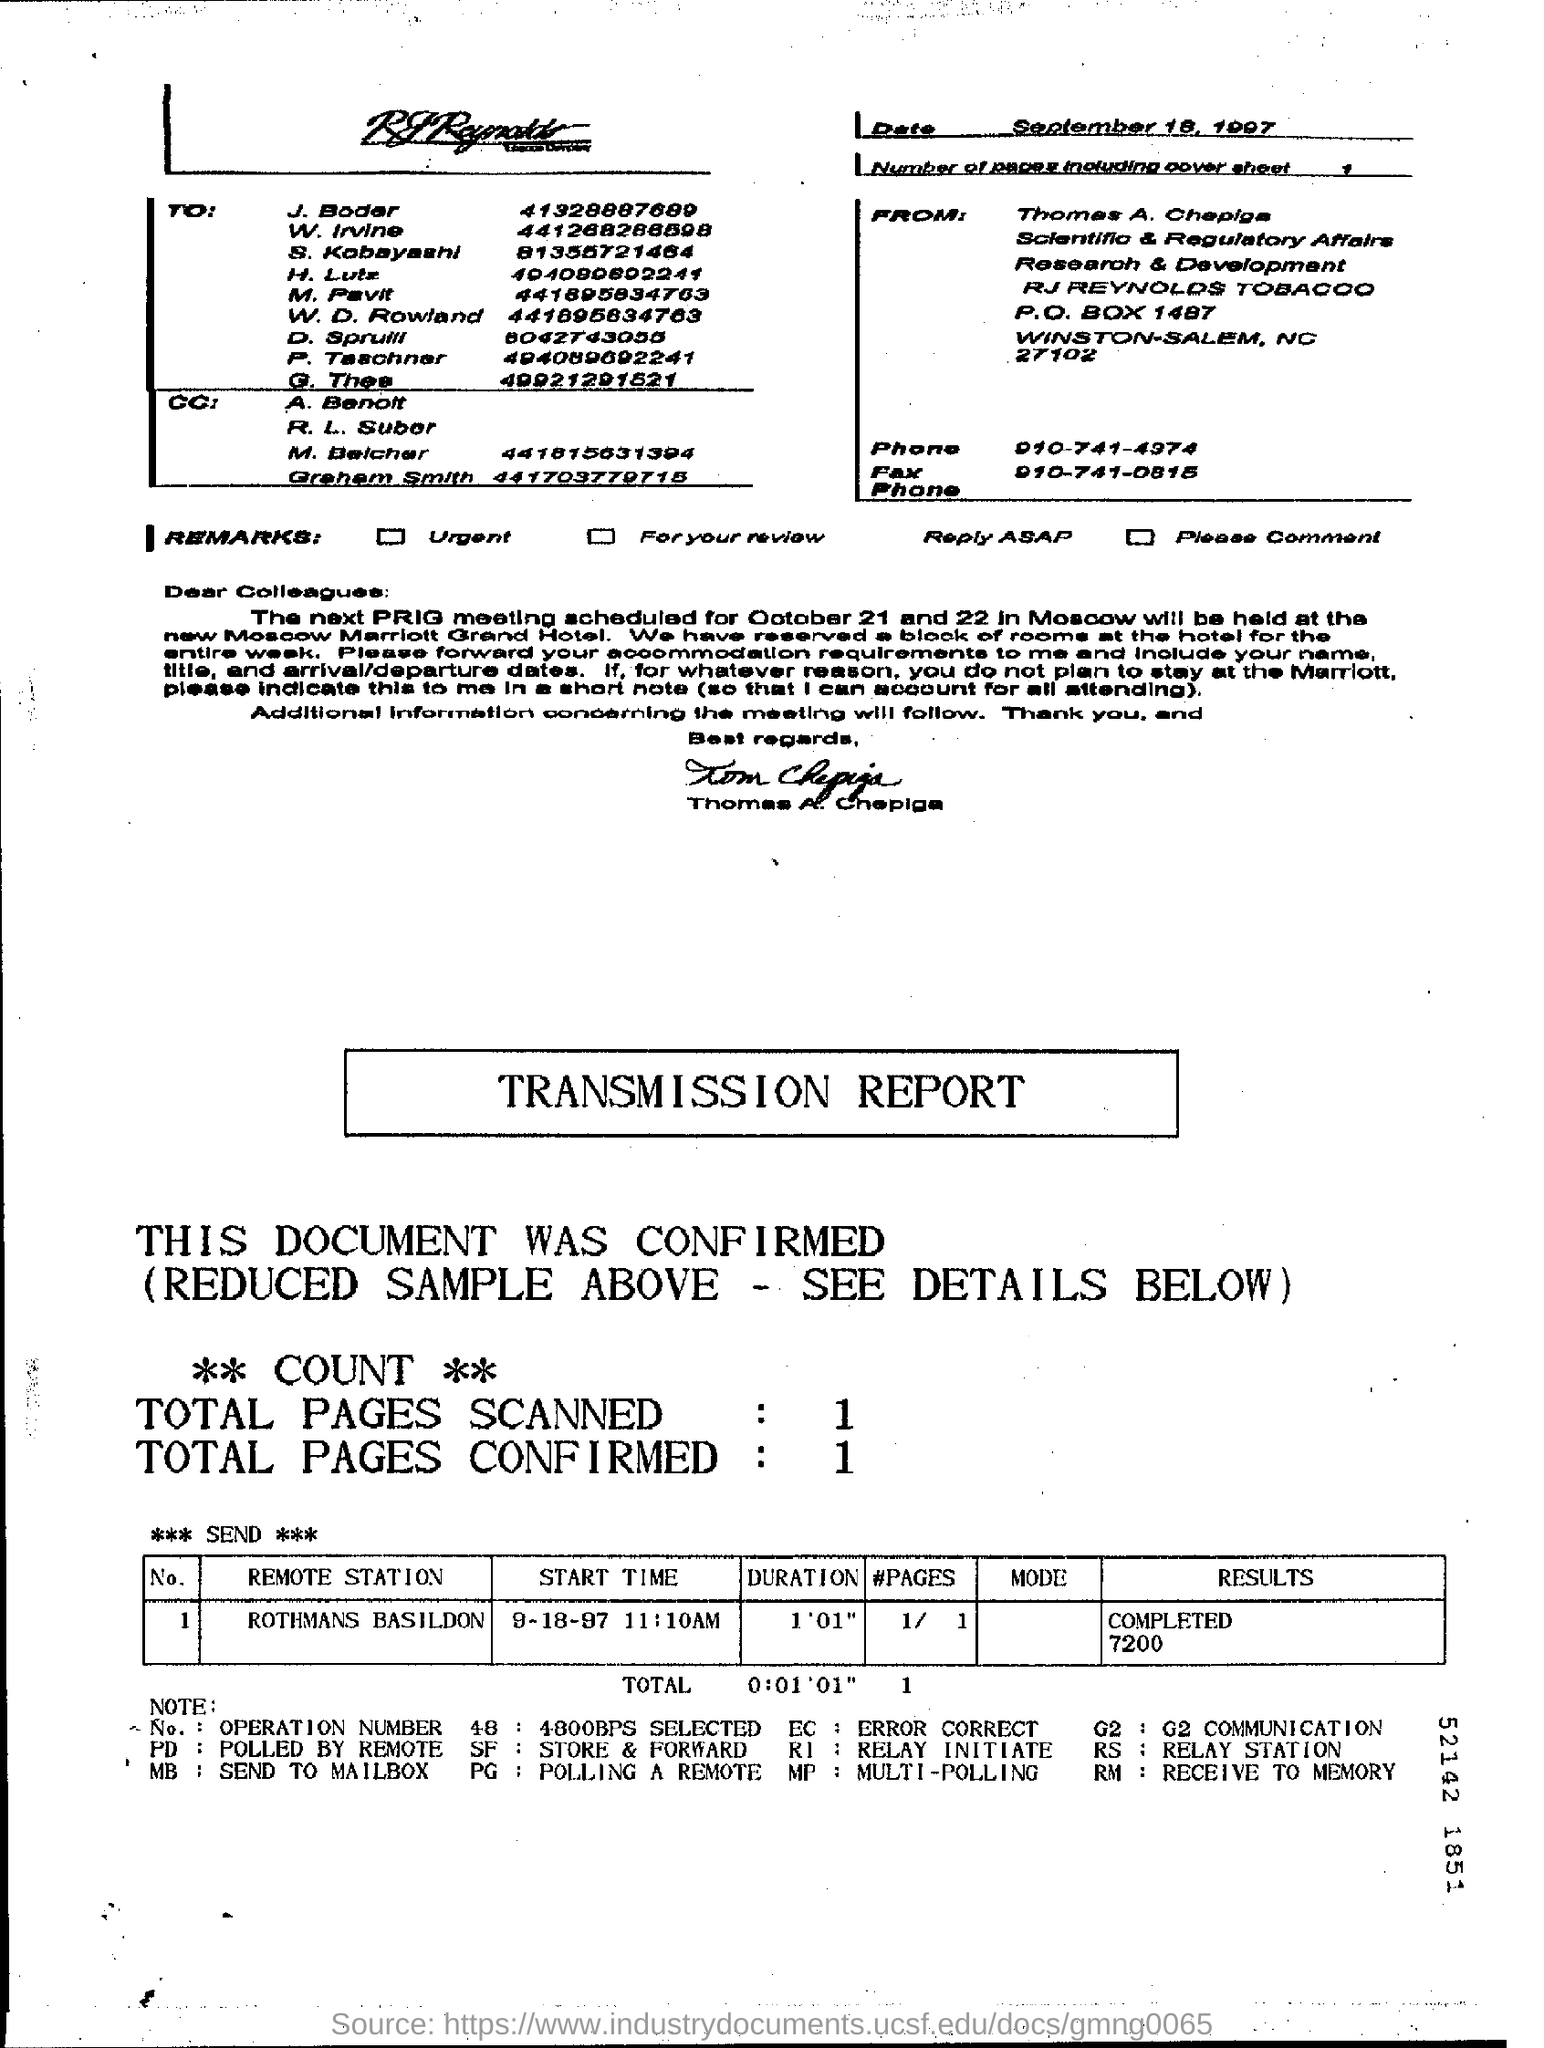Who is this letter from?
Ensure brevity in your answer.  Thomas A. Chepiga. What are the Total pages Scanned?
Keep it short and to the point. 1. What are the Total pages Confirmed?
Provide a short and direct response. 1. What is the "Remote Station" in the table?
Your answer should be very brief. Rothmans Basildon. What is the "DURATION" for "Remote Station" "ROTHMANS BASILDON"?
Offer a very short reply. 1'01". What is the "RESULTS" for "Remote Station" "ROTHMANS BASILDON"?
Your response must be concise. Completed 7200. What is the "START TIME" for "Remote Station" "ROTHMANS BASILDON"?
Your response must be concise. 9-18-97 11:10AM. 